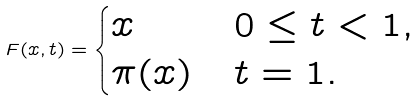<formula> <loc_0><loc_0><loc_500><loc_500>F ( x , t ) = \begin{cases} x & 0 \leq t < 1 , \\ \pi ( x ) & t = 1 . \end{cases}</formula> 